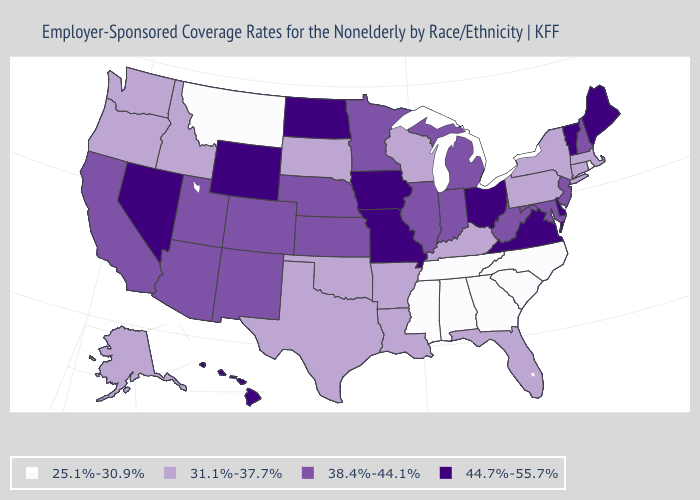What is the value of Hawaii?
Short answer required. 44.7%-55.7%. Name the states that have a value in the range 44.7%-55.7%?
Short answer required. Delaware, Hawaii, Iowa, Maine, Missouri, Nevada, North Dakota, Ohio, Vermont, Virginia, Wyoming. Name the states that have a value in the range 31.1%-37.7%?
Write a very short answer. Alaska, Arkansas, Connecticut, Florida, Idaho, Kentucky, Louisiana, Massachusetts, New York, Oklahoma, Oregon, Pennsylvania, South Dakota, Texas, Washington, Wisconsin. Among the states that border Vermont , which have the lowest value?
Write a very short answer. Massachusetts, New York. What is the value of New Jersey?
Give a very brief answer. 38.4%-44.1%. What is the highest value in states that border Wyoming?
Be succinct. 38.4%-44.1%. What is the value of South Carolina?
Write a very short answer. 25.1%-30.9%. Does Montana have the lowest value in the West?
Be succinct. Yes. Name the states that have a value in the range 31.1%-37.7%?
Short answer required. Alaska, Arkansas, Connecticut, Florida, Idaho, Kentucky, Louisiana, Massachusetts, New York, Oklahoma, Oregon, Pennsylvania, South Dakota, Texas, Washington, Wisconsin. What is the value of California?
Keep it brief. 38.4%-44.1%. Among the states that border Connecticut , which have the lowest value?
Concise answer only. Rhode Island. Name the states that have a value in the range 25.1%-30.9%?
Answer briefly. Alabama, Georgia, Mississippi, Montana, North Carolina, Rhode Island, South Carolina, Tennessee. Name the states that have a value in the range 38.4%-44.1%?
Give a very brief answer. Arizona, California, Colorado, Illinois, Indiana, Kansas, Maryland, Michigan, Minnesota, Nebraska, New Hampshire, New Jersey, New Mexico, Utah, West Virginia. What is the highest value in the MidWest ?
Give a very brief answer. 44.7%-55.7%. 